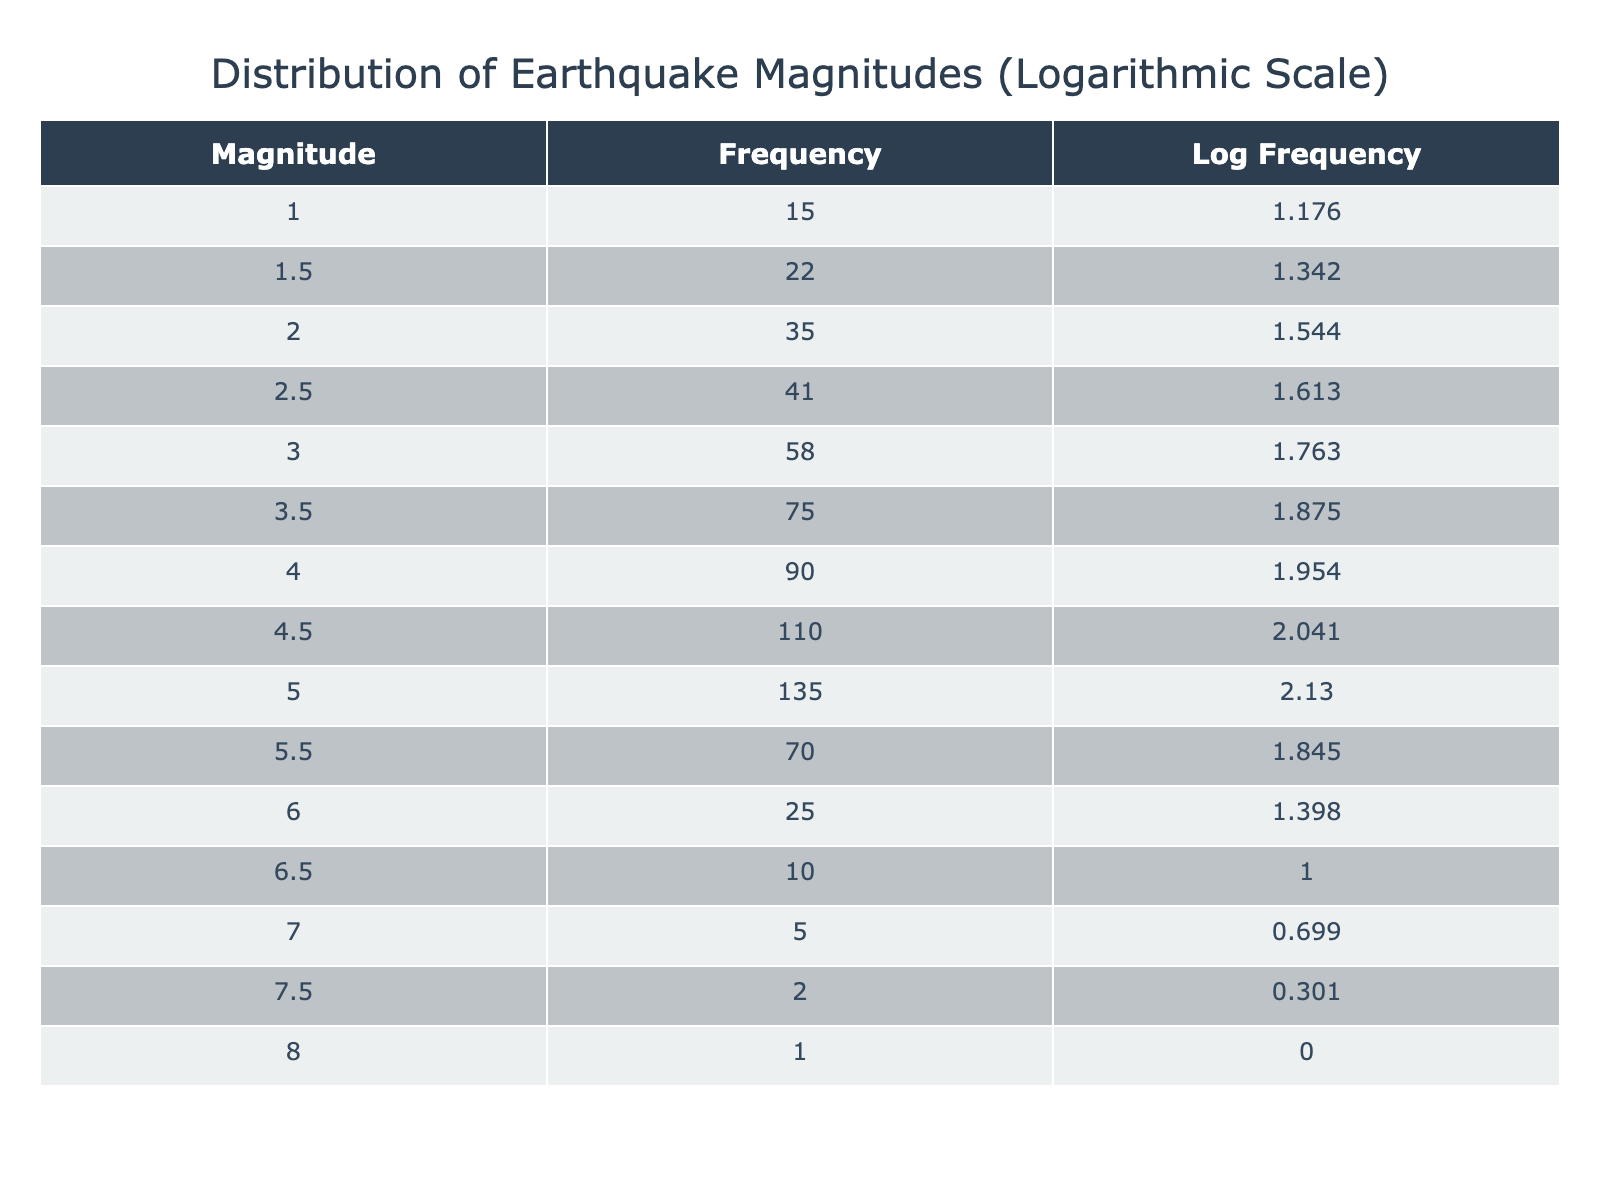What is the frequency of earthquakes with a magnitude of 4.0? The table shows the frequency next to each corresponding magnitude. For a magnitude of 4.0, the frequency is directly listed as 90.
Answer: 90 What is the log frequency for a magnitude of 5.5? To find the log frequency for a magnitude of 5.5, we look up the frequency (70) in the table and identify the corresponding log frequency, which is rounded to 2.845.
Answer: 2.845 How many earthquake magnitudes have a frequency greater than 50? We need to filter the table for frequencies greater than 50, which are 58, 75, 90, 110, and 135. There are five magnitudes that meet this criterion.
Answer: 5 Is the frequency of earthquakes with a magnitude of 1.0 greater than that of 6.0? We refer to the table and compare the frequency of 1.0 (15) against 6.0 (25). Since 15 is less than 25, the statement is false.
Answer: No What is the sum of frequencies for magnitudes 2.5 and 3.5? The frequency for magnitude 2.5 is 41, and for 3.5 it is 75. Adding these two values gives 41 + 75 = 116.
Answer: 116 Calculate the average frequency of the highest two magnitudes. The highest two magnitudes are 7.0 (5) and 8.0 (1). First, sum the frequencies: 5 + 1 = 6. Then divide by the number of magnitudes (2): 6/2 = 3. Therefore, the average frequency is 3.
Answer: 3 What is the difference in frequency between magnitudes 4.5 and 5.0? To find the difference, we subtract the frequency of 5.0 (135) from 4.5 (110): 110 - 135 = -25. This shows that there are 25 fewer earthquakes at magnitude 5.0 compared to 4.5.
Answer: -25 Are there more than 10 earthquakes with a magnitude of 7.5? The table indicates that the frequency of earthquakes at a magnitude of 7.5 is 2. Since 2 is not greater than 10, the answer is false.
Answer: No What is the log frequency for the lowest recorded earthquake magnitude? The lowest magnitude is 1.0, which has a frequency of 15. Calculating the logarithmic frequency gives us log10(15), which is approximately 1.176 after rounding.
Answer: 1.176 